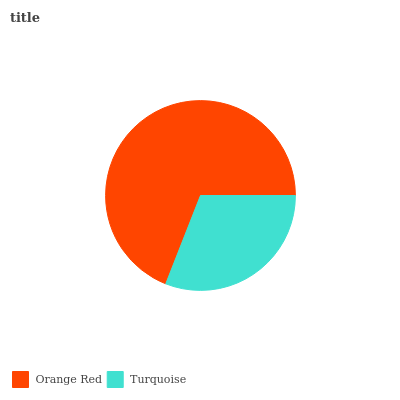Is Turquoise the minimum?
Answer yes or no. Yes. Is Orange Red the maximum?
Answer yes or no. Yes. Is Turquoise the maximum?
Answer yes or no. No. Is Orange Red greater than Turquoise?
Answer yes or no. Yes. Is Turquoise less than Orange Red?
Answer yes or no. Yes. Is Turquoise greater than Orange Red?
Answer yes or no. No. Is Orange Red less than Turquoise?
Answer yes or no. No. Is Orange Red the high median?
Answer yes or no. Yes. Is Turquoise the low median?
Answer yes or no. Yes. Is Turquoise the high median?
Answer yes or no. No. Is Orange Red the low median?
Answer yes or no. No. 